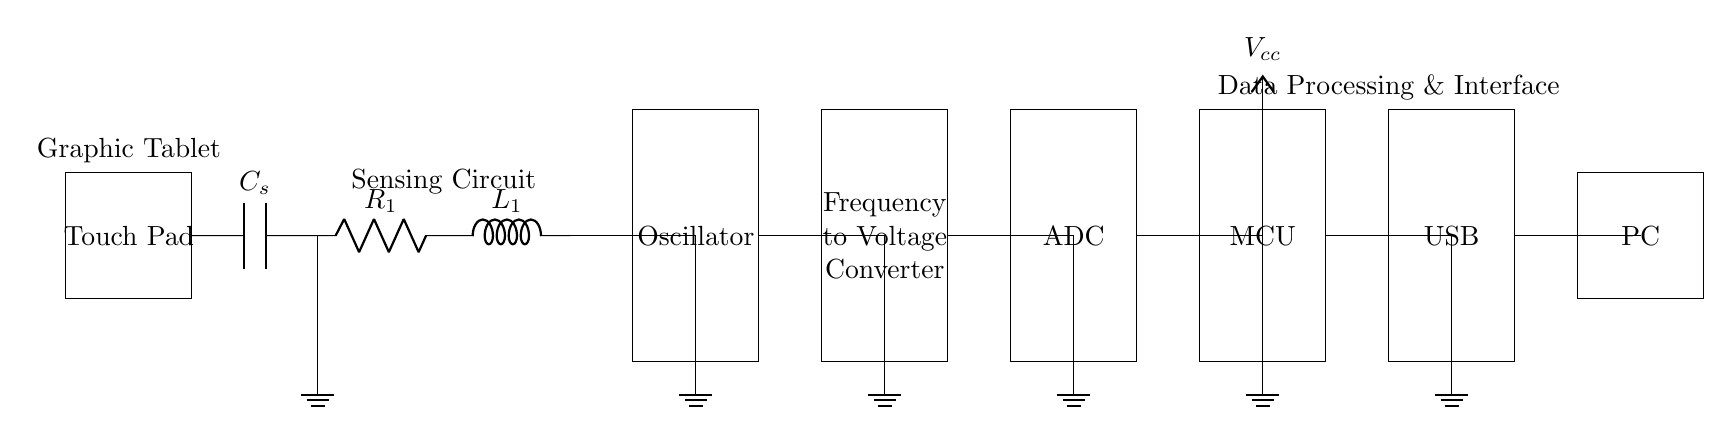What is the main function of the touch pad? The touch pad detects user interaction through touch, enabling the graphic tablet to recognize input.
Answer: Input detection What components make up the sensing circuit? The sensing circuit consists of a capacitor labeled C_s, a resistor labeled R_1, and an inductor labeled L_1.
Answer: C_s, R_1, L_1 How many processing stages are in the circuit? The circuit has four processing stages: an oscillator, a frequency to voltage converter, an ADC, and a microcontroller.
Answer: Four What type of interface is used to connect to the computer? The circuit uses a USB interface to connect and communicate with the computer.
Answer: USB What is the purpose of the frequency to voltage converter? The frequency to voltage converter translates frequency signals from the oscillator into corresponding voltage signals for further processing.
Answer: Signal conversion What is the voltage supply for the microcontroller? The microcontroller is powered by a voltage supply denoted as V_cc, which is a common power supply voltage in circuits.
Answer: V_cc 